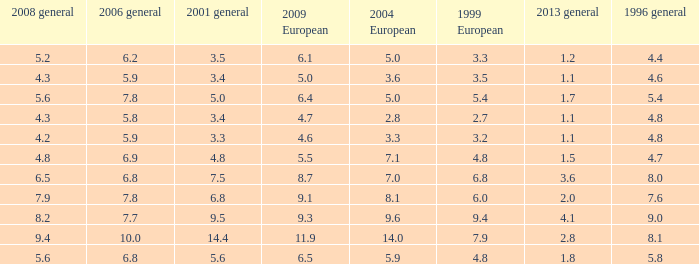What was the value for 2004 European with less than 7.5 in general 2001, less than 6.4 in 2009 European, and less than 1.5 in general 2013 with 4.3 in 2008 general? 3.6, 2.8. 